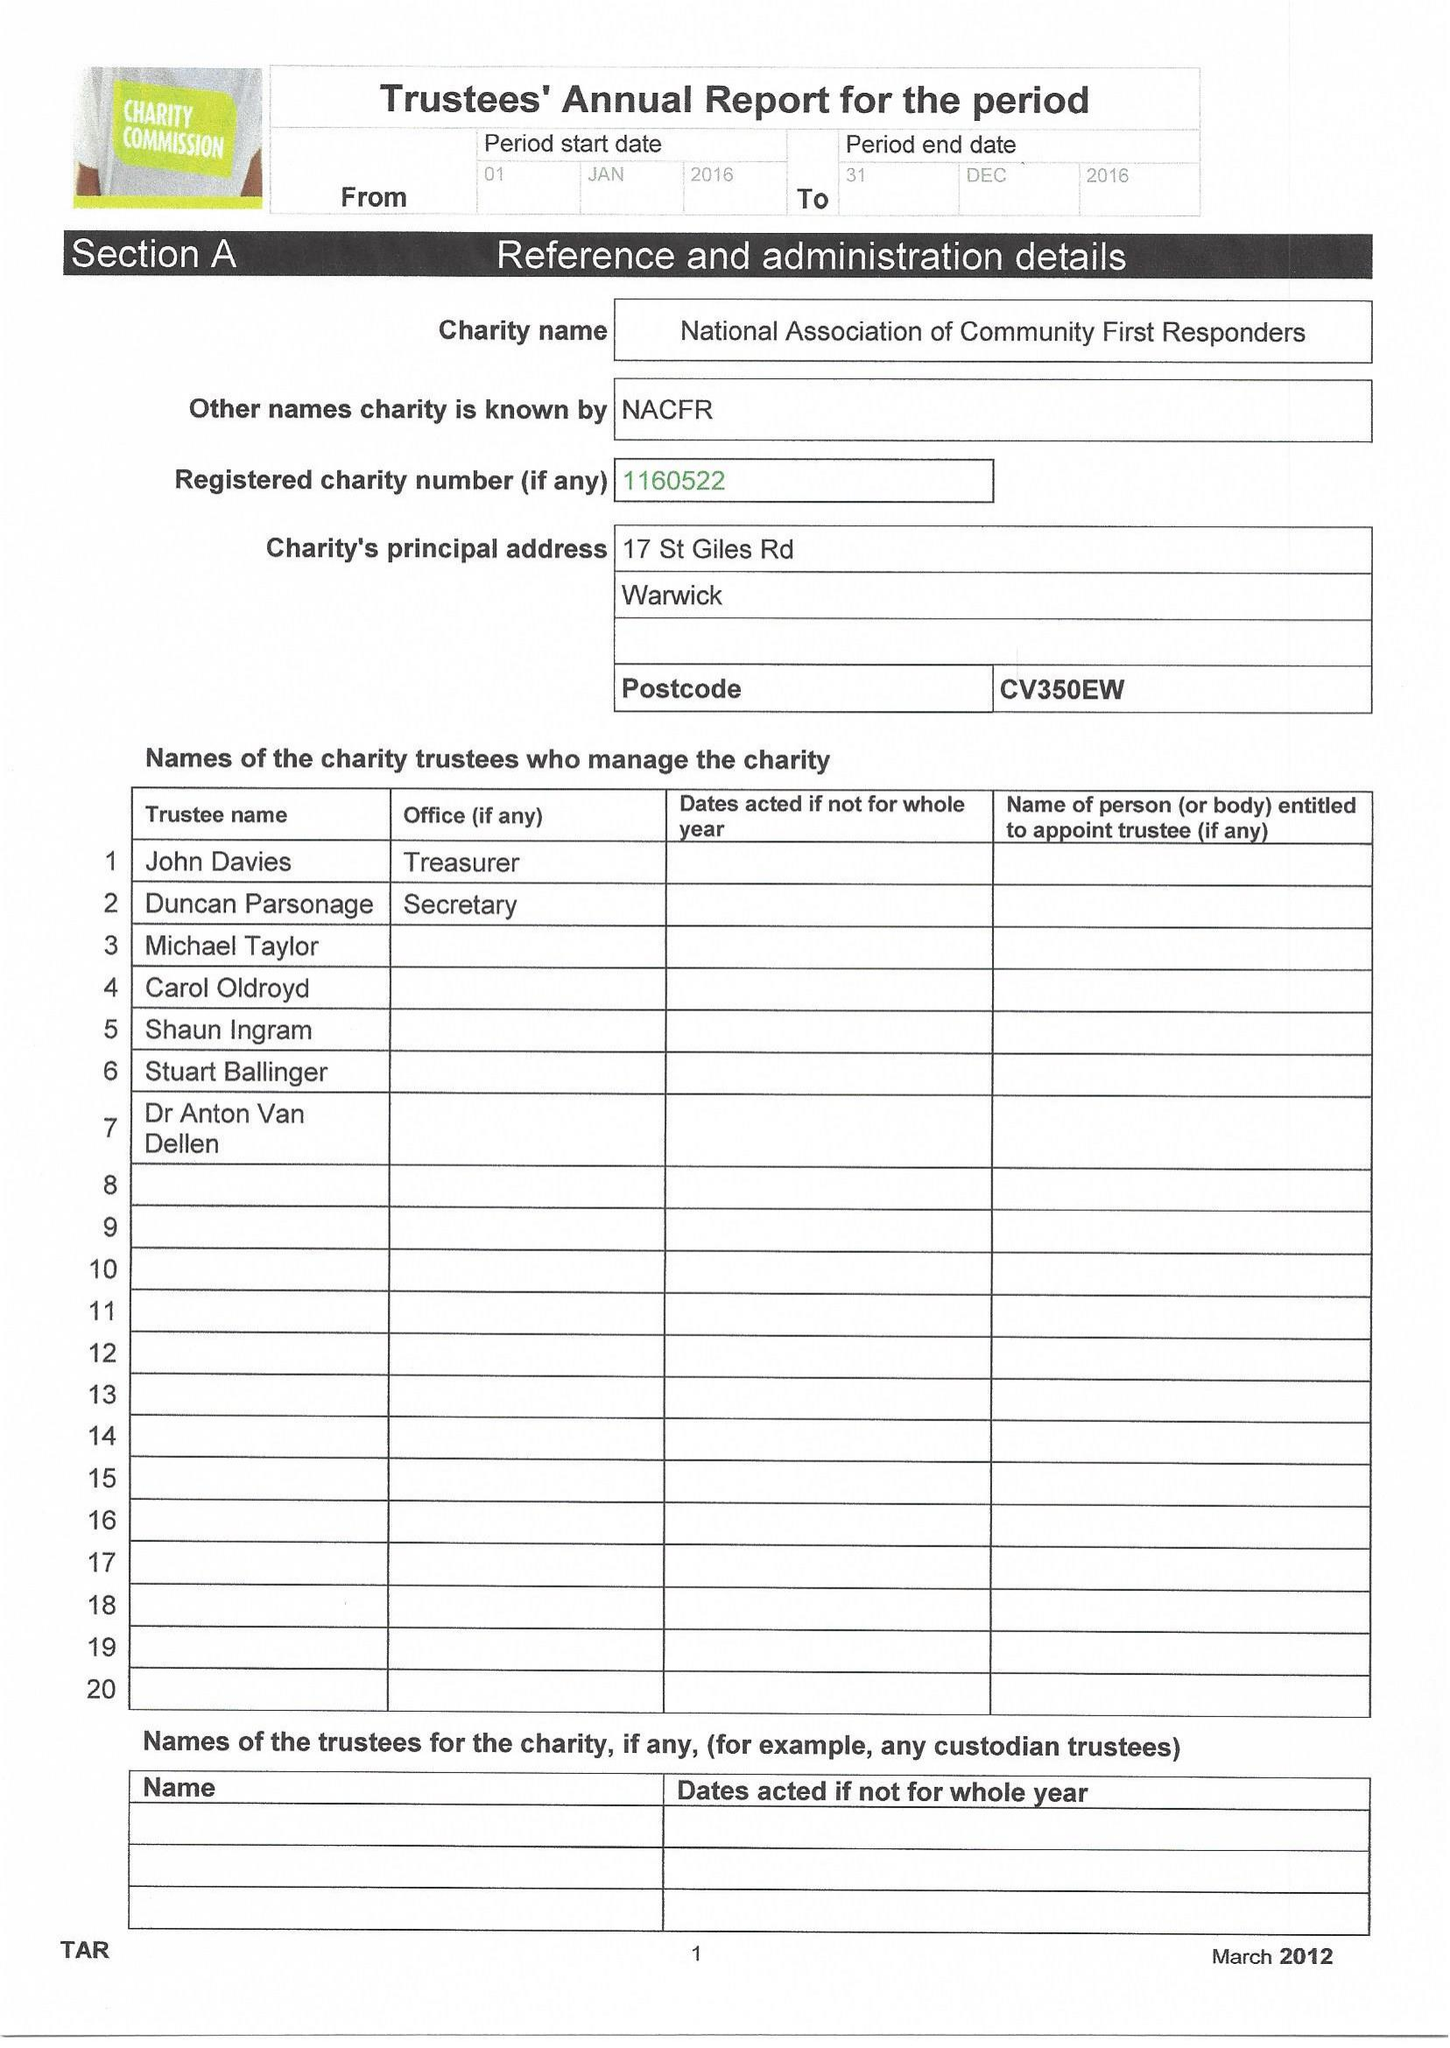What is the value for the address__postcode?
Answer the question using a single word or phrase. CV35 0EW 